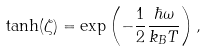Convert formula to latex. <formula><loc_0><loc_0><loc_500><loc_500>\tanh ( \zeta ) = \exp \left ( - \frac { 1 } { 2 } \frac { \hbar { \omega } } { k _ { B } T } \right ) ,</formula> 